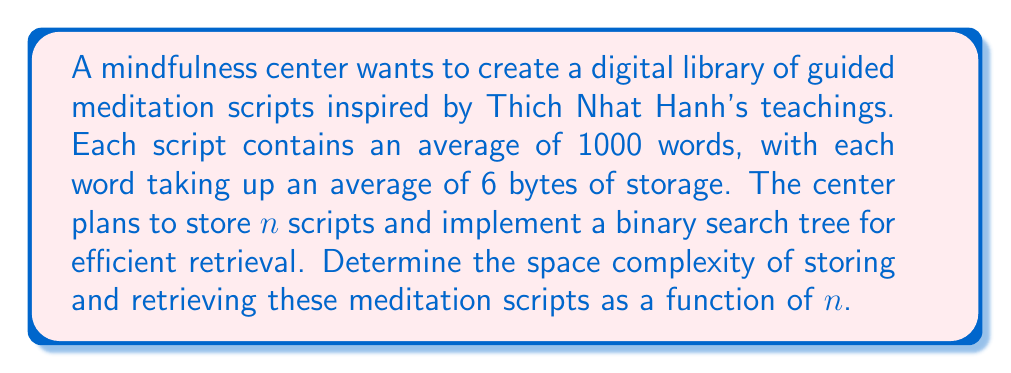Could you help me with this problem? To determine the space complexity, we need to consider both the storage of the scripts and the data structure used for retrieval.

1. Storage of scripts:
   - Each script contains 1000 words on average
   - Each word takes up 6 bytes on average
   - Total bytes per script = 1000 * 6 = 6000 bytes
   - For $n$ scripts, the storage required is $6000n$ bytes

2. Binary Search Tree (BST) for retrieval:
   - The BST will store $n$ nodes, one for each script
   - Each node typically contains:
     a. A key (e.g., script title or ID)
     b. A pointer to the actual script data
     c. Two pointers for left and right child nodes
   - Assuming 8 bytes for each pointer and 16 bytes for the key, each node requires approximately 40 bytes

3. Total space complexity:
   - Scripts: $6000n$ bytes
   - BST: $40n$ bytes
   - Total: $6000n + 40n = 6040n$ bytes

The space complexity is therefore $O(n)$, as it grows linearly with the number of scripts.

For retrieval, the BST allows for efficient searching with a time complexity of $O(\log n)$ on average, but this does not affect the space complexity.
Answer: The space complexity of storing and retrieving guided meditation scripts is $O(n)$, where $n$ is the number of scripts. 